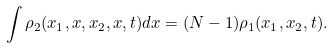<formula> <loc_0><loc_0><loc_500><loc_500>\int \rho _ { 2 } ( x _ { 1 } , x , x _ { 2 } , x , t ) d x = ( N - 1 ) \rho _ { 1 } ( x _ { 1 } , x _ { 2 } , t ) .</formula> 